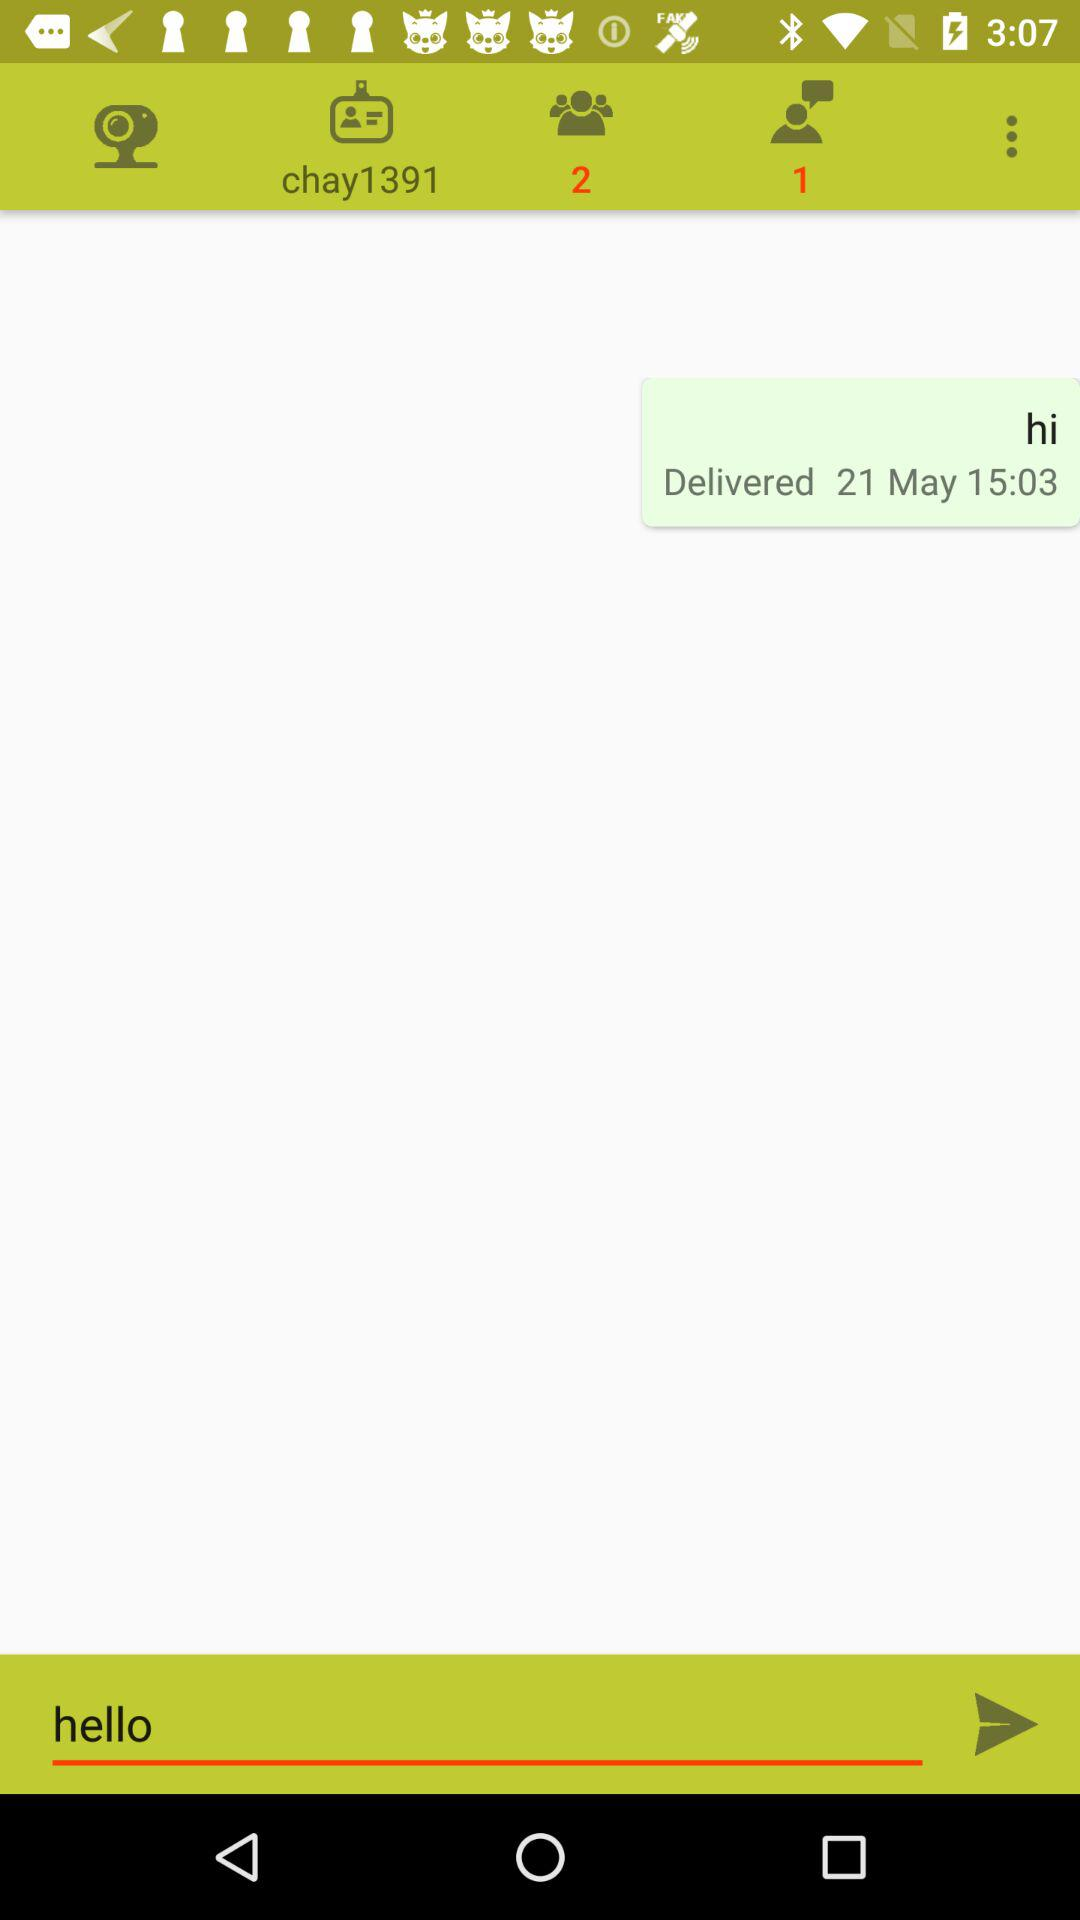What is the number of unread chats? The number of unread chats is 1. 